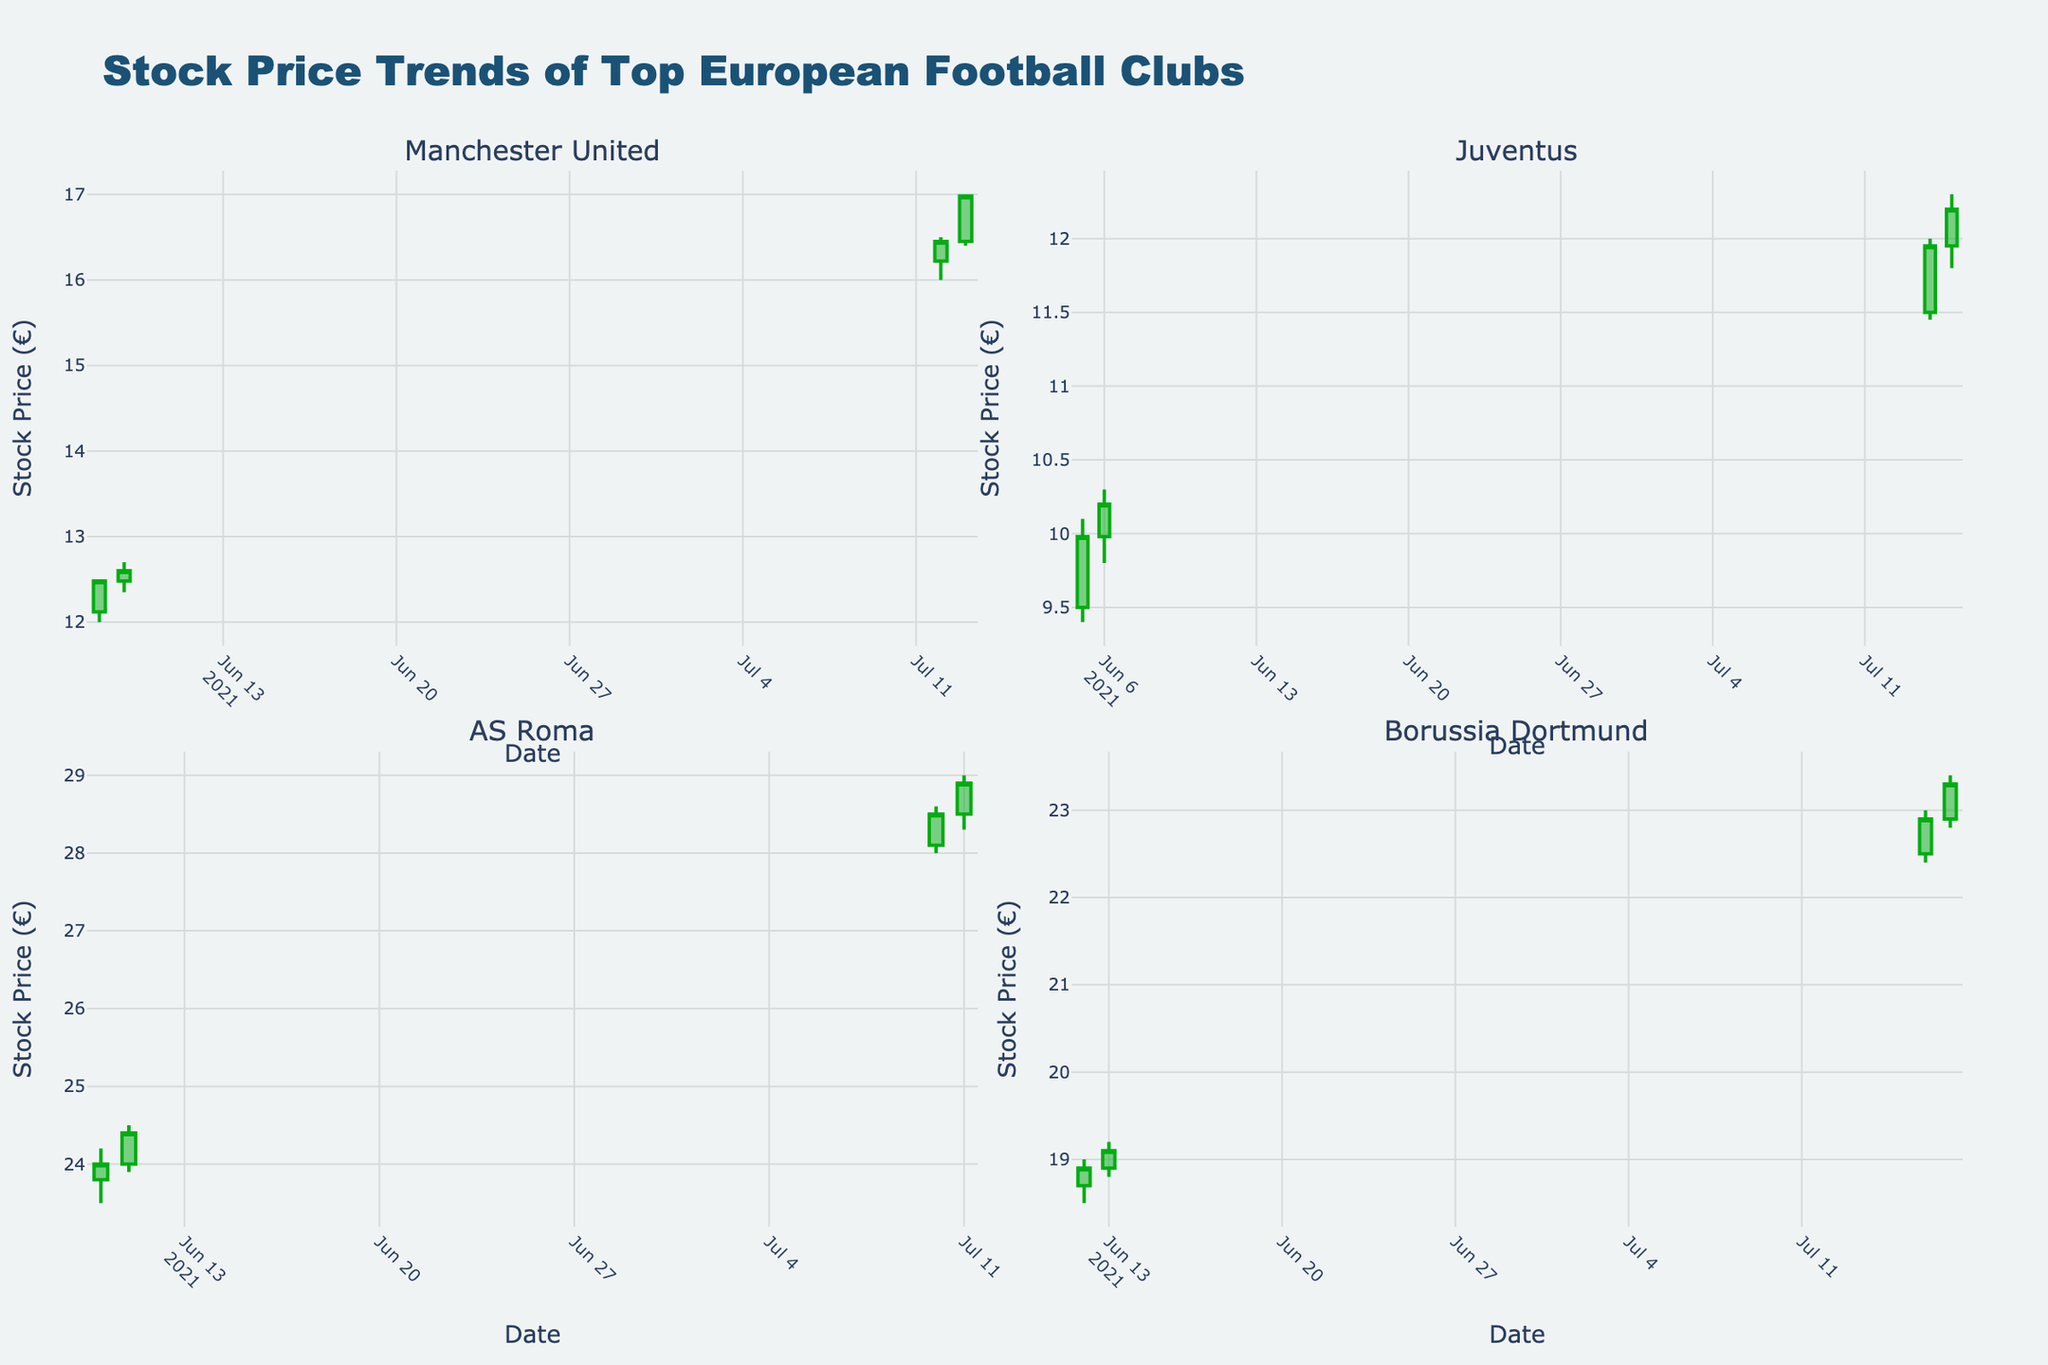What is the title of the plot? The plot title is displayed at the top and reads "Stock Price Trends of Top European Football Clubs".
Answer: Stock Price Trends of Top European Football Clubs What are the colors used for the increasing and decreasing lines in the candlestick plot? The increasing lines are colored green, and the decreasing lines are colored red as commonly used in stock plots.
Answer: Green for increasing, Red for decreasing Which club had the highest stock price on July 12, 2021? On July 12, 2021, checking the respective candlestick in Manchester United's subplot shows that the highest price reached was 16.50.
Answer: Manchester United How did AS Roma's stock price change from June 10, 2021, to June 11, 2021? On June 10, 2021, AS Roma's closing price was 24.00. The following day, June 11, 2021, the closing price increased to 24.40.
Answer: Increased by 0.40 Which club had the highest volume traded on June 5, 2021? Looking at the subplots, it is clear that Juventus had the highest volume traded, 540,000 on June 5, 2021.
Answer: Juventus Between July 14, 2021, and July 15, 2021, did Juventus' stock price increase or decrease? Observing the candlesticks for Juventus on July 14 and July 15, the closing price increased from 11.95 to 12.20.
Answer: Increased What date did Borussia Dortmund’s stock price close at 19.10? Examining the subplot for Borussia Dortmund, on June 13, 2021, the closing price was 19.10.
Answer: June 13, 2021 Which club had the highest closing stock price overall? By comparing the maximum values of the closing price candlesticks across all subplots, AS Roma reached the highest closing stock price of 29.00 on July 11, 2021.
Answer: AS Roma Among the clubs represented, which one exhibited the most significant increase in stock price between consecutive days? By inspecting all subplots and comparing the increases, Manchester United had a notable increase from 12.60 on June 9 to 16.22 on July 12.
Answer: Manchester United How does the stock volume for Borussia Dortmund on July 17, 2021 compare with its volume on July 16, 2021? The volume on July 16 was 450,000, while on July 17, it was slightly lower at 440,000.
Answer: Decreased by 10,000 